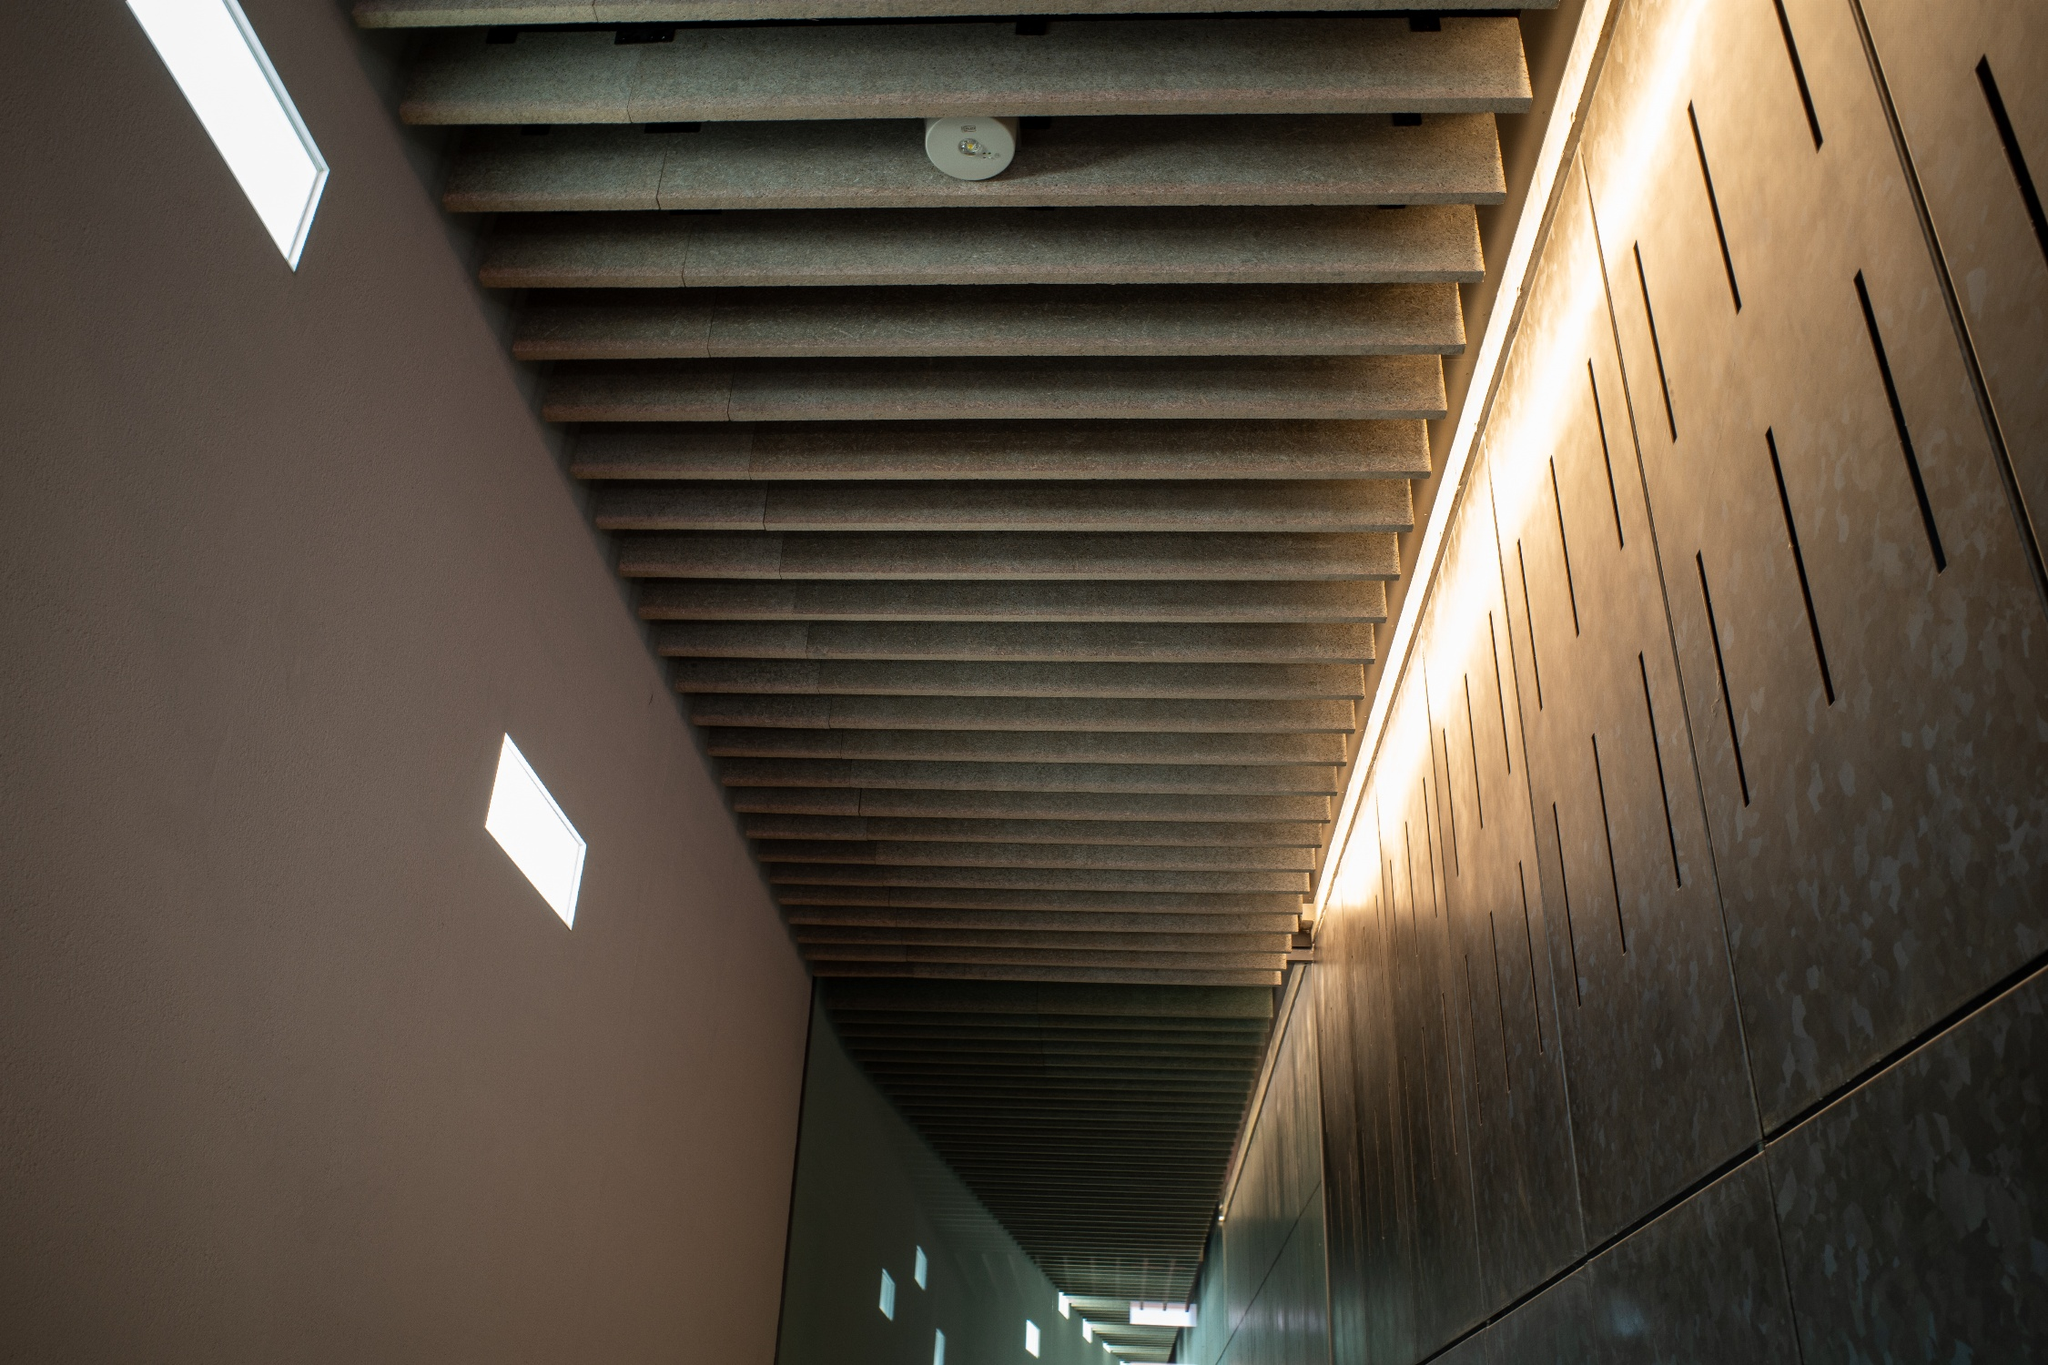In a parallel universe, what unique feature could this hallway have? In a parallel universe, this hallway features a series of floating, translucent orbs that emit a soft, pulsating light in various colors. These orbs have the ability to adjust their positions and brightness based on the emotional state of the people walking through. Additionally, the stone walls are embedded with tiny sentient crystals that hum subtly, creating a soothing symphony that changes to match the mood within the hallway. As travelers move through, the hallway becomes a dynamic, living art piece that interacts with each individual in a unique and deeply personal way. 